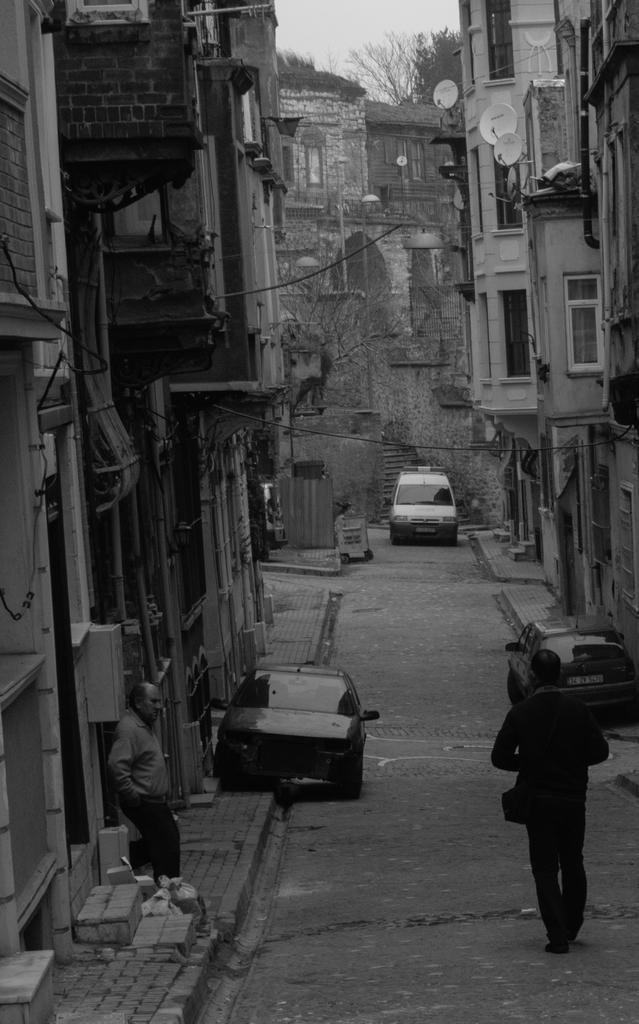In one or two sentences, can you explain what this image depicts? This is a black and white image. In this image we can see a group of buildings with windows and the staircase. We can also see some dishes, trees, some vehicles and a person on the pathway, a person standing on the footpath, some wires and the sky which looks cloudy. 